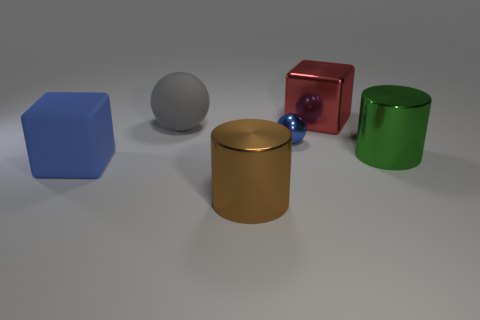Is there anything else that is the same size as the blue ball?
Your answer should be compact. No. What number of large rubber things are the same color as the tiny metallic object?
Your response must be concise. 1. What is the shape of the big shiny thing on the left side of the block to the right of the brown thing?
Your answer should be compact. Cylinder. How many cylinders are either small objects or big blue rubber things?
Offer a terse response. 0. There is a big block that is the same color as the small metal object; what is its material?
Give a very brief answer. Rubber. There is a rubber thing behind the large blue rubber cube; is its shape the same as the blue object that is behind the green metal object?
Keep it short and to the point. Yes. There is a large object that is in front of the gray rubber thing and left of the large brown shiny cylinder; what is its color?
Provide a short and direct response. Blue. There is a tiny sphere; is it the same color as the big block to the left of the brown thing?
Provide a short and direct response. Yes. What size is the shiny thing that is behind the rubber cube and in front of the tiny metal thing?
Offer a very short reply. Large. How many other objects are there of the same color as the large rubber ball?
Offer a very short reply. 0. 